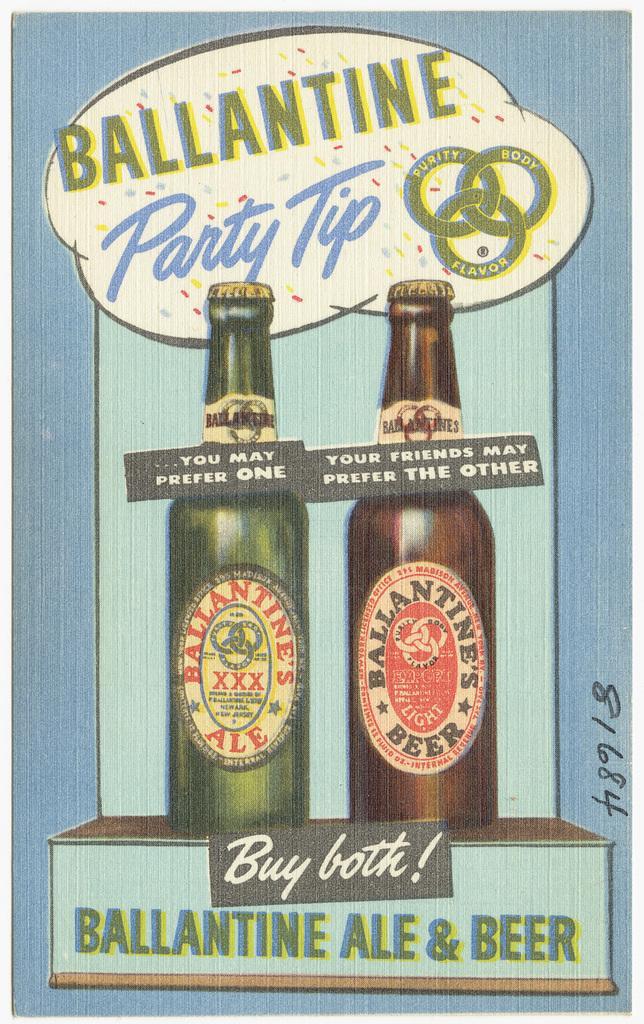Could you give a brief overview of what you see in this image? In this picture we can see poster, in this poster we can see bottles and text. 